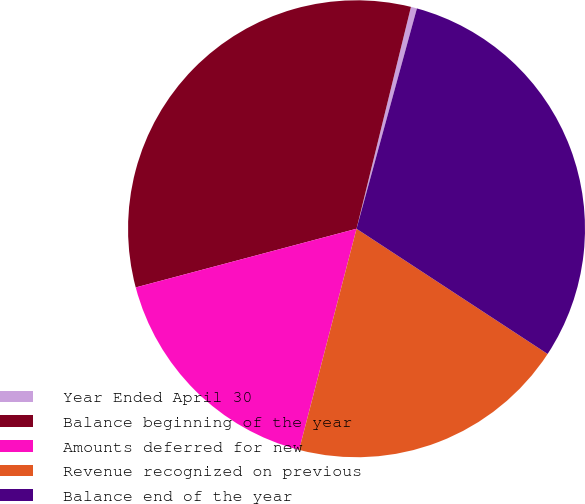Convert chart to OTSL. <chart><loc_0><loc_0><loc_500><loc_500><pie_chart><fcel>Year Ended April 30<fcel>Balance beginning of the year<fcel>Amounts deferred for new<fcel>Revenue recognized on previous<fcel>Balance end of the year<nl><fcel>0.43%<fcel>32.96%<fcel>16.82%<fcel>19.81%<fcel>29.97%<nl></chart> 